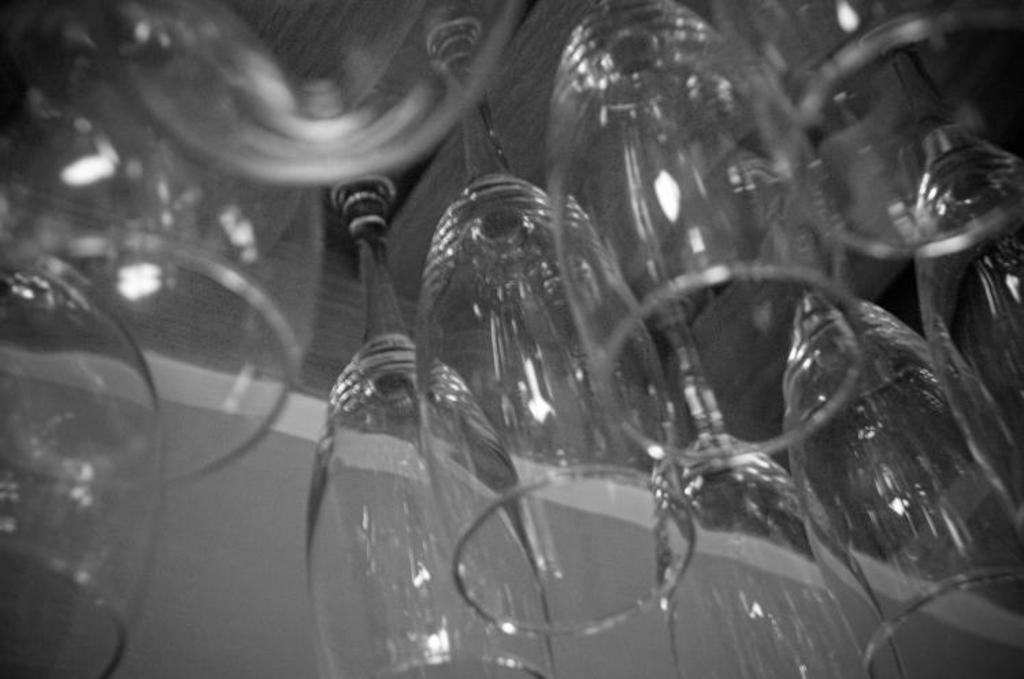What objects are present in the image? There are glasses in the image. What type of cloud can be seen floating above the glasses in the image? There is no cloud present in the image; it only features glasses. What is the texture of the feather resting on the glasses in the image? There is no feather present in the image; it only features glasses. 